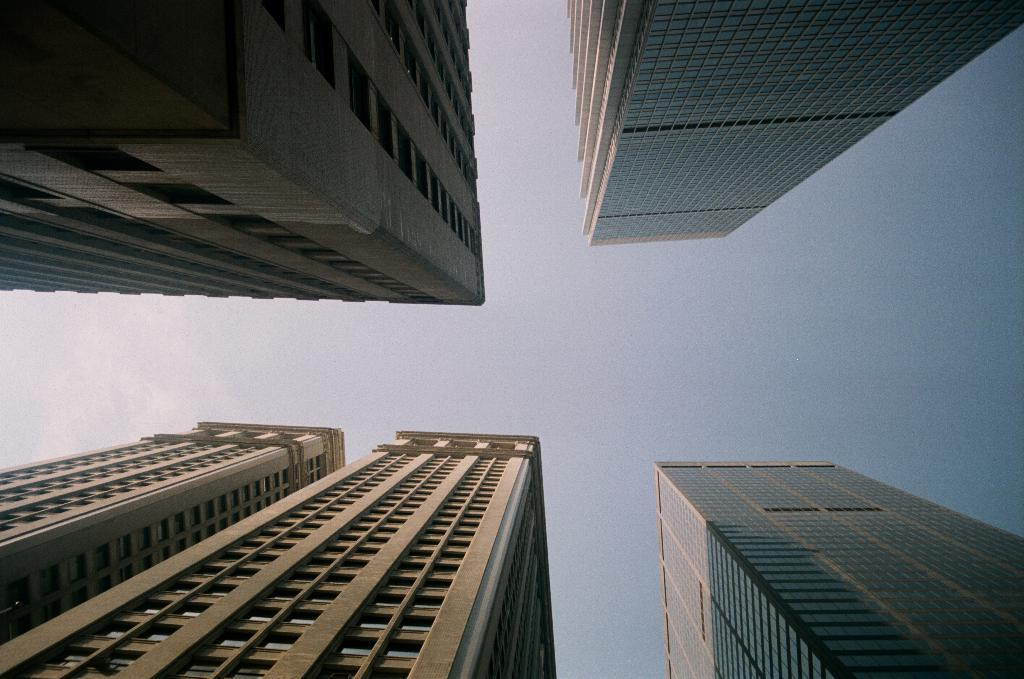What type of structures can be seen in the image? There are buildings in the image. What part of the natural environment is visible in the image? The sky is visible in the image. Where is the shelf located in the image? There is no shelf present in the image. What type of muscle can be seen in the image? There are no muscles visible in the image; it features buildings and the sky. 